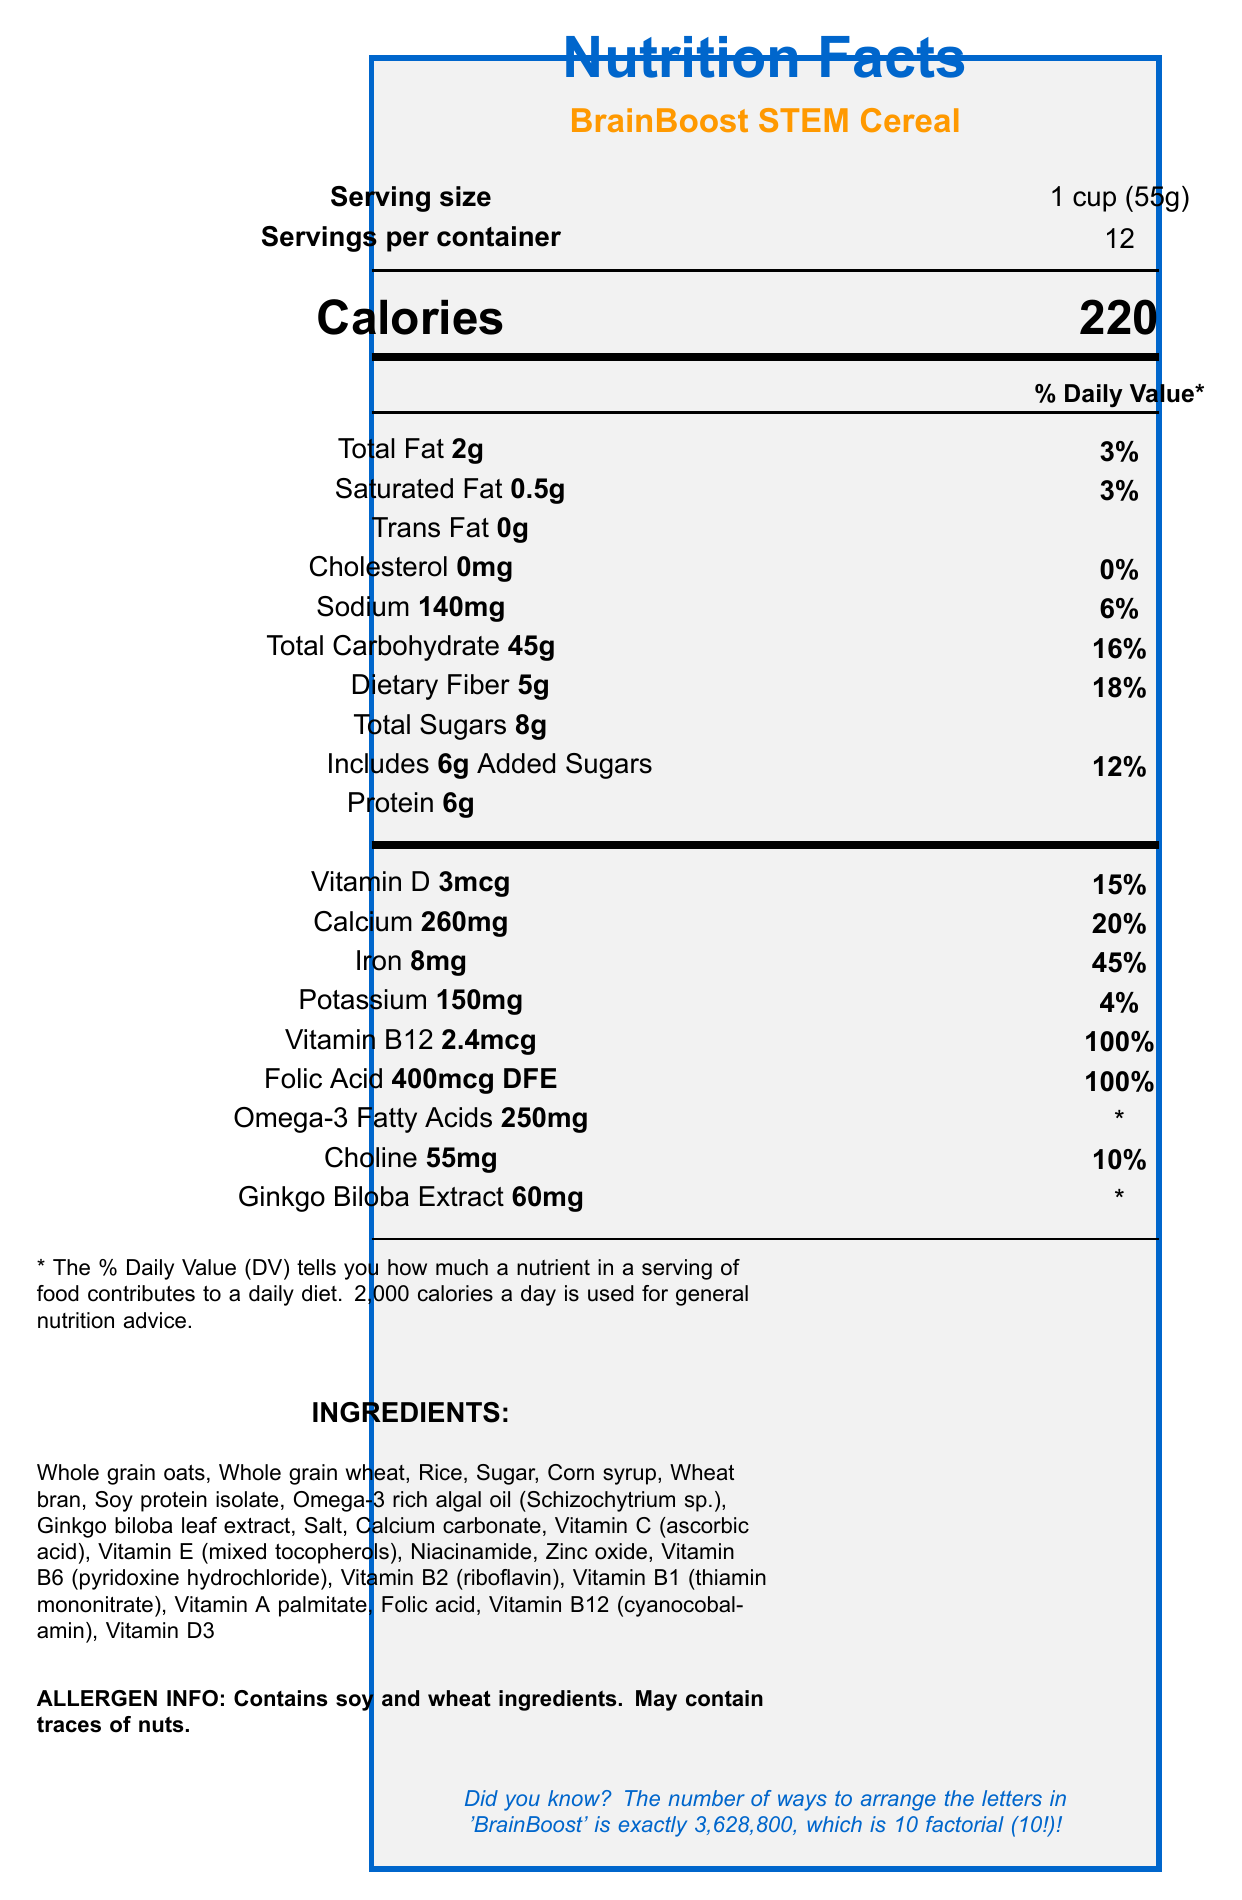what is the serving size for BrainBoost STEM Cereal? The serving size is explicitly mentioned near the top left section of the document under the title "Serving size."
Answer: 1 cup (55g) how many servings are in one container of BrainBoost STEM Cereal? The document states "Servings per container" as 12, located just below the serving size information.
Answer: 12 how many calories are there in one serving of BrainBoost STEM Cereal? The calorie content is highlighted in large font near the top middle section of the document, labeled "Calories."
Answer: 220 what percentage of the daily value of iron is provided in one serving of BrainBoost STEM Cereal? The percentage daily value of iron is listed under the nutrients section as 45%, adjacent to "Iron."
Answer: 45% which ingredient in BrainBoost STEM Cereal provides omega-3 fatty acids? This specific ingredient is listed in the ingredients section under "Omega-3 rich algal oil (Schizochytrium sp.)."
Answer: Omega-3 rich algal oil (Schizochytrium sp.) what type of allergens are present in BrainBoost STEM Cereal? The allergen information is clearly stated near the bottom of the document in bold font.
Answer: Contains soy and wheat ingredients. May contain traces of nuts. how many grams of dietary fiber are in one serving? A. 3g B. 4g C. 5g D. 6g Dietary fiber is stated as 5g per serving in the nutrients table.
Answer: C what is the daily value percentage of Vitamin B12 provided by one serving of BrainBoost STEM Cereal? A. 50% B. 100% C. 25% D. 75% Vitamin B12 provides 100% of the daily value per serving, listed under the vitamins and minerals section.
Answer: B does BrainBoost STEM Cereal contain any cholesterol? The document states "Cholesterol 0mg" under the fats, cholesterol, and sodium section.
Answer: No are there any added sugars in BrainBoost STEM Cereal? The document lists "Includes 6g Added Sugars" under the carbohydrate section.
Answer: Yes summarize the main idea of the BrainBoost STEM Cereal Nutrition Facts Label. This summary describes the product details, serving information, nutrient content, and target audience as presented in the nutrition facts document.
Answer: BrainBoost STEM Cereal is a vitamin-fortified cereal formulated to support cognitive function and sustain energy levels, particularly targeting academics in STEM fields. It contains various nutrients including high levels of Vitamin B12 and iron, with a serving size of 1 cup (55g) providing 220 calories. The cereal includes essential minerals and vitamins, dietary fiber, proteins, and has specified allergen information. what is the source of Vitamin D in BrainBoost STEM Cereal? The document does not specify the source of Vitamin D, only that it contains Vitamin D3.
Answer: Not enough information 